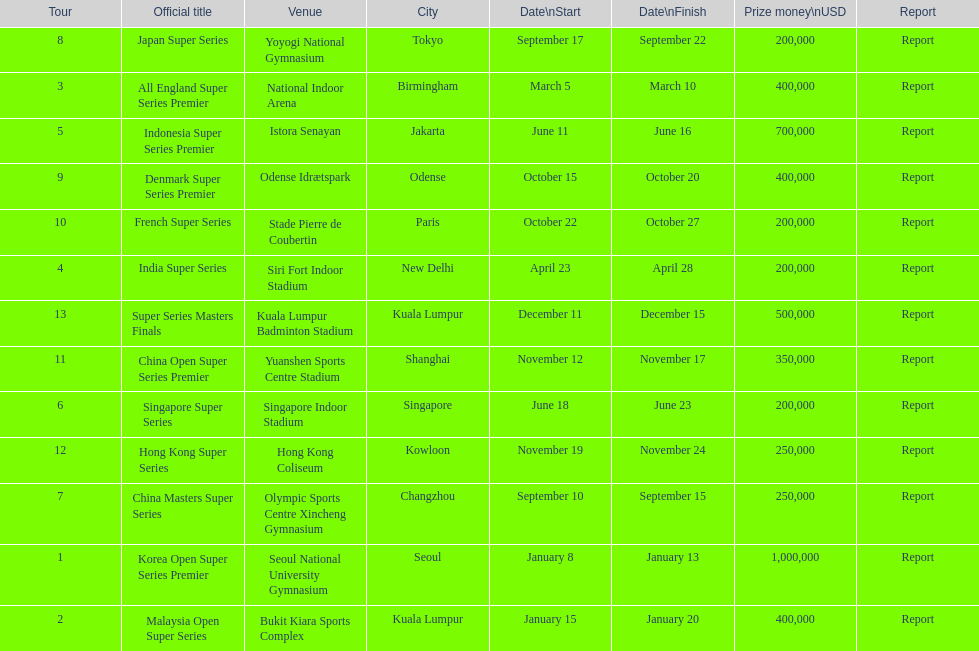Which has the same prize money as the french super series? Japan Super Series, Singapore Super Series, India Super Series. 